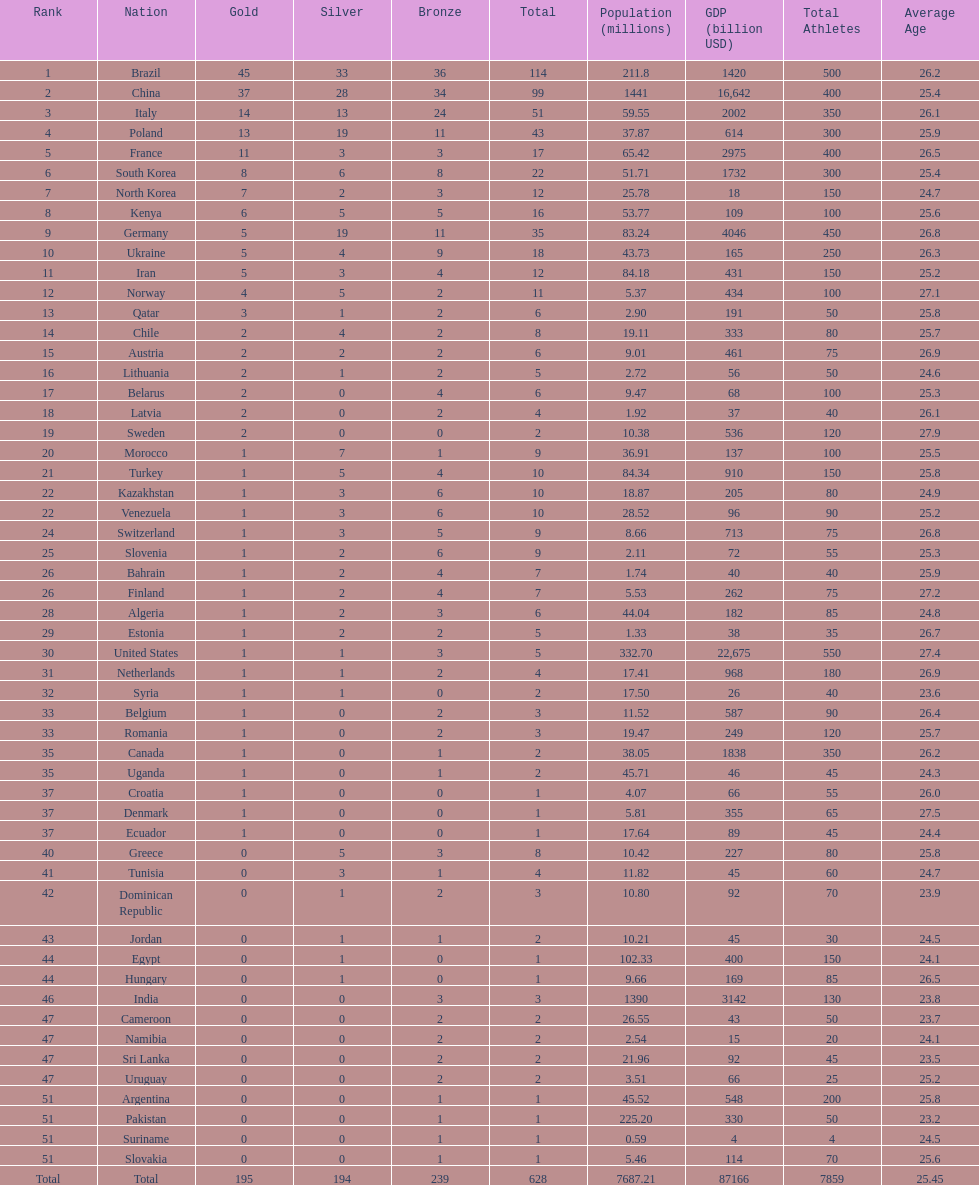How many gold medals did germany earn? 5. 